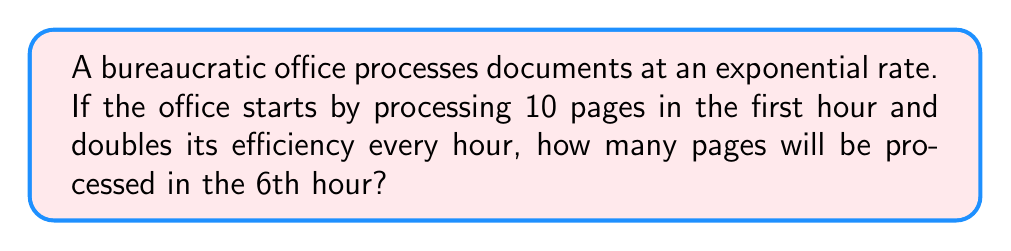Provide a solution to this math problem. Let's approach this step-by-step:

1) We start with 10 pages in the first hour.

2) The number of pages doubles every hour, which means we multiply by 2 each time.

3) We can represent this with the exponential function:
   $f(n) = 10 \cdot 2^{n-1}$
   where $n$ is the hour number and $f(n)$ is the number of pages processed in that hour.

4) We want to know about the 6th hour, so we plug in $n = 6$:

   $f(6) = 10 \cdot 2^{6-1}$

5) Simplify the exponent:
   $f(6) = 10 \cdot 2^5$

6) Calculate $2^5$:
   $2^5 = 2 \cdot 2 \cdot 2 \cdot 2 \cdot 2 = 32$

7) Multiply:
   $f(6) = 10 \cdot 32 = 320$

Therefore, in the 6th hour, the office will process 320 pages.
Answer: 320 pages 